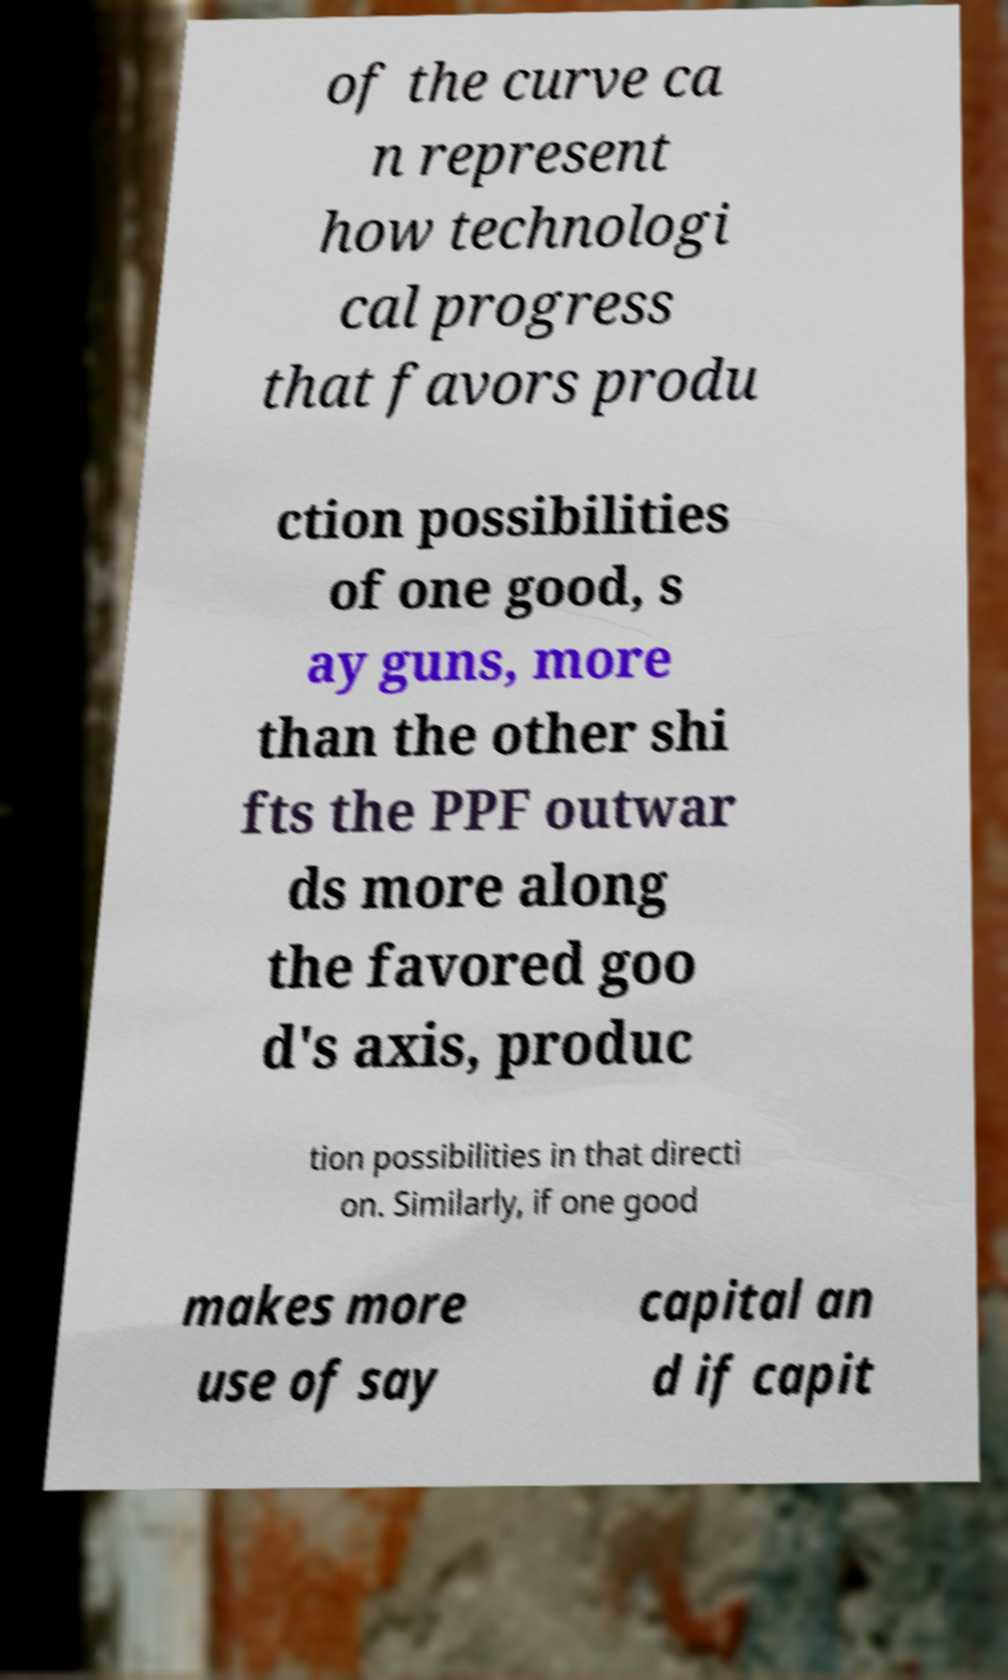Please read and relay the text visible in this image. What does it say? of the curve ca n represent how technologi cal progress that favors produ ction possibilities of one good, s ay guns, more than the other shi fts the PPF outwar ds more along the favored goo d's axis, produc tion possibilities in that directi on. Similarly, if one good makes more use of say capital an d if capit 